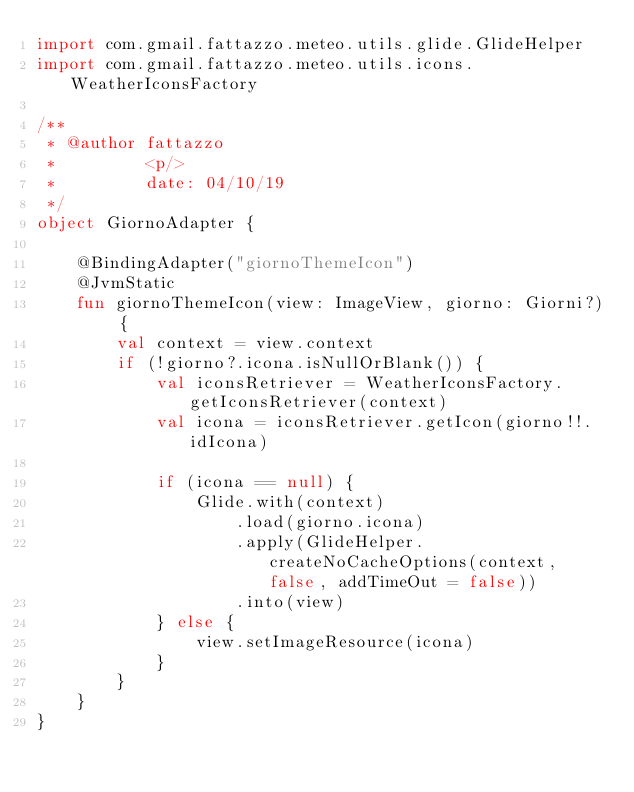Convert code to text. <code><loc_0><loc_0><loc_500><loc_500><_Kotlin_>import com.gmail.fattazzo.meteo.utils.glide.GlideHelper
import com.gmail.fattazzo.meteo.utils.icons.WeatherIconsFactory

/**
 * @author fattazzo
 *         <p/>
 *         date: 04/10/19
 */
object GiornoAdapter {

    @BindingAdapter("giornoThemeIcon")
    @JvmStatic
    fun giornoThemeIcon(view: ImageView, giorno: Giorni?) {
        val context = view.context
        if (!giorno?.icona.isNullOrBlank()) {
            val iconsRetriever = WeatherIconsFactory.getIconsRetriever(context)
            val icona = iconsRetriever.getIcon(giorno!!.idIcona)

            if (icona == null) {
                Glide.with(context)
                    .load(giorno.icona)
                    .apply(GlideHelper.createNoCacheOptions(context, false, addTimeOut = false))
                    .into(view)
            } else {
                view.setImageResource(icona)
            }
        }
    }
}</code> 